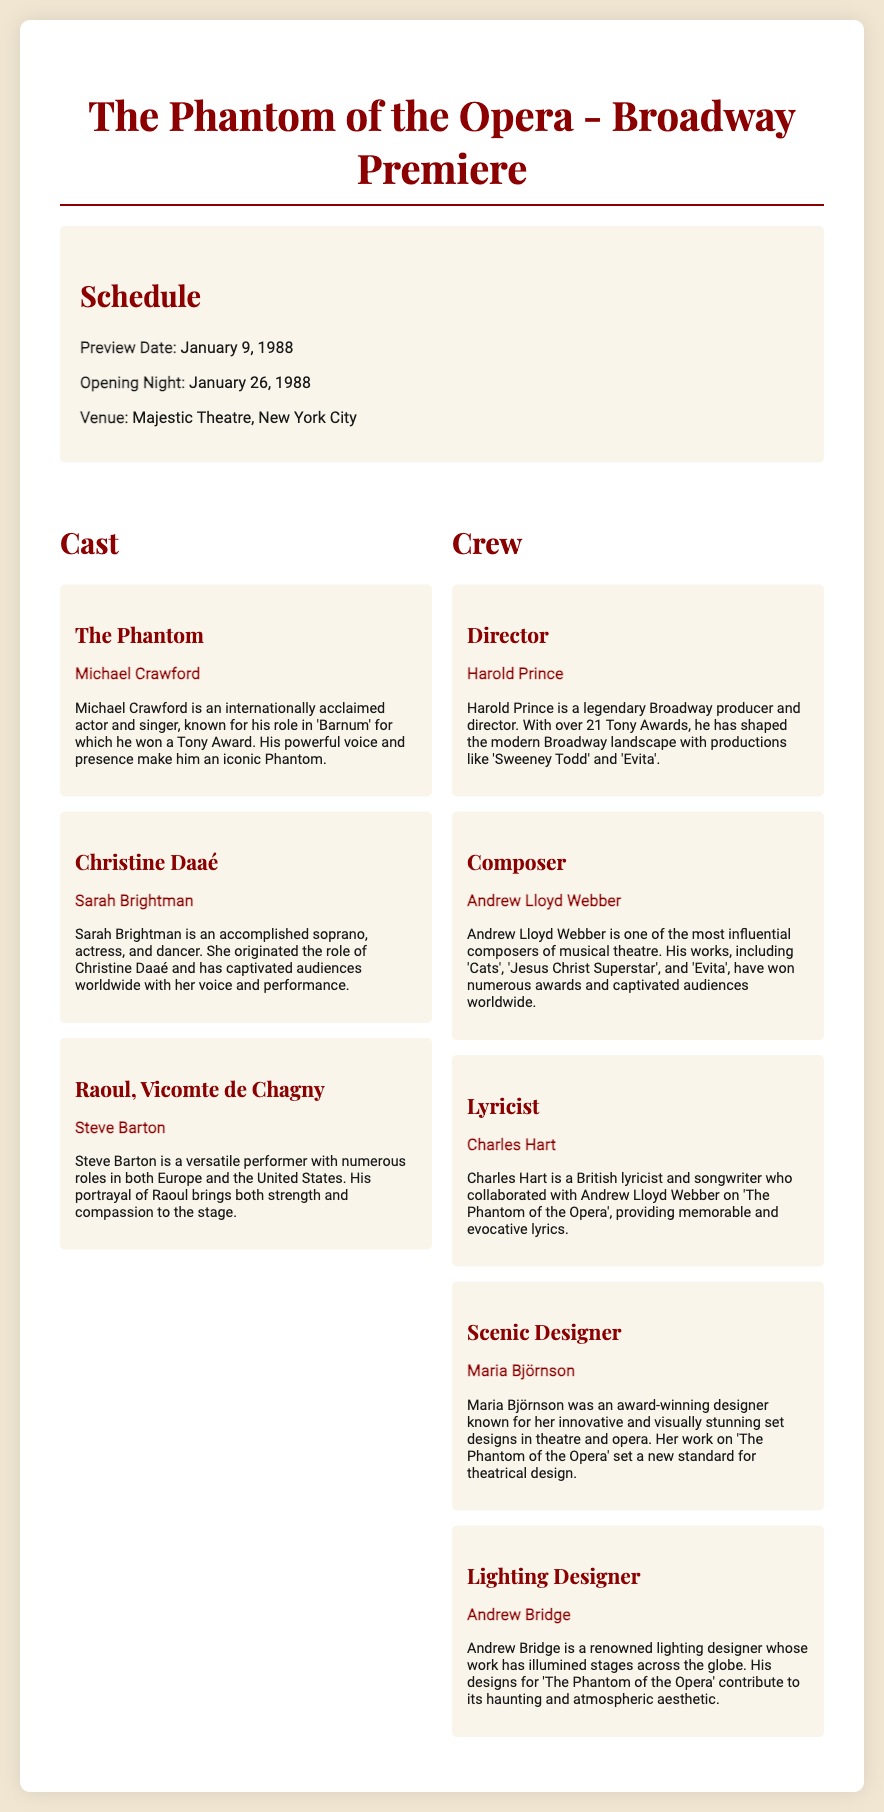What is the preview date? The preview date is specifically mentioned in the schedule section of the document.
Answer: January 9, 1988 Who portrays Christine Daaé? Christine Daaé's portrayal is directly linked to the actor listed in the cast section of the document.
Answer: Sarah Brightman How many Tony Awards has Harold Prince won? The document mentions that Harold Prince has won over 21 Tony Awards.
Answer: 21 What is the opening night date? The opening night date is provided in the schedule section of the document.
Answer: January 26, 1988 Who is the scenic designer for the play? The name of the scenic designer is explicitly mentioned in the crew section of the document.
Answer: Maria Björnson What role does Michael Crawford play? The document specifies the role associated with Michael Crawford in the cast section.
Answer: The Phantom Who is the composer of "The Phantom of the Opera"? The composer is identified in the crew section of the document.
Answer: Andrew Lloyd Webber What type of performance is highlighted in this document? The document type features the Broadway premiere of a musical production, a specific format of theatre performance.
Answer: Musical How does Steve Barton's portrayal of Raoul contribute to the character? The document describes Steve Barton's characterization of Raoul in terms of strength and compassion.
Answer: Strength and compassion What is the venue for the premiere? The venue for the performance is clearly mentioned in the schedule section of the document.
Answer: Majestic Theatre, New York City 